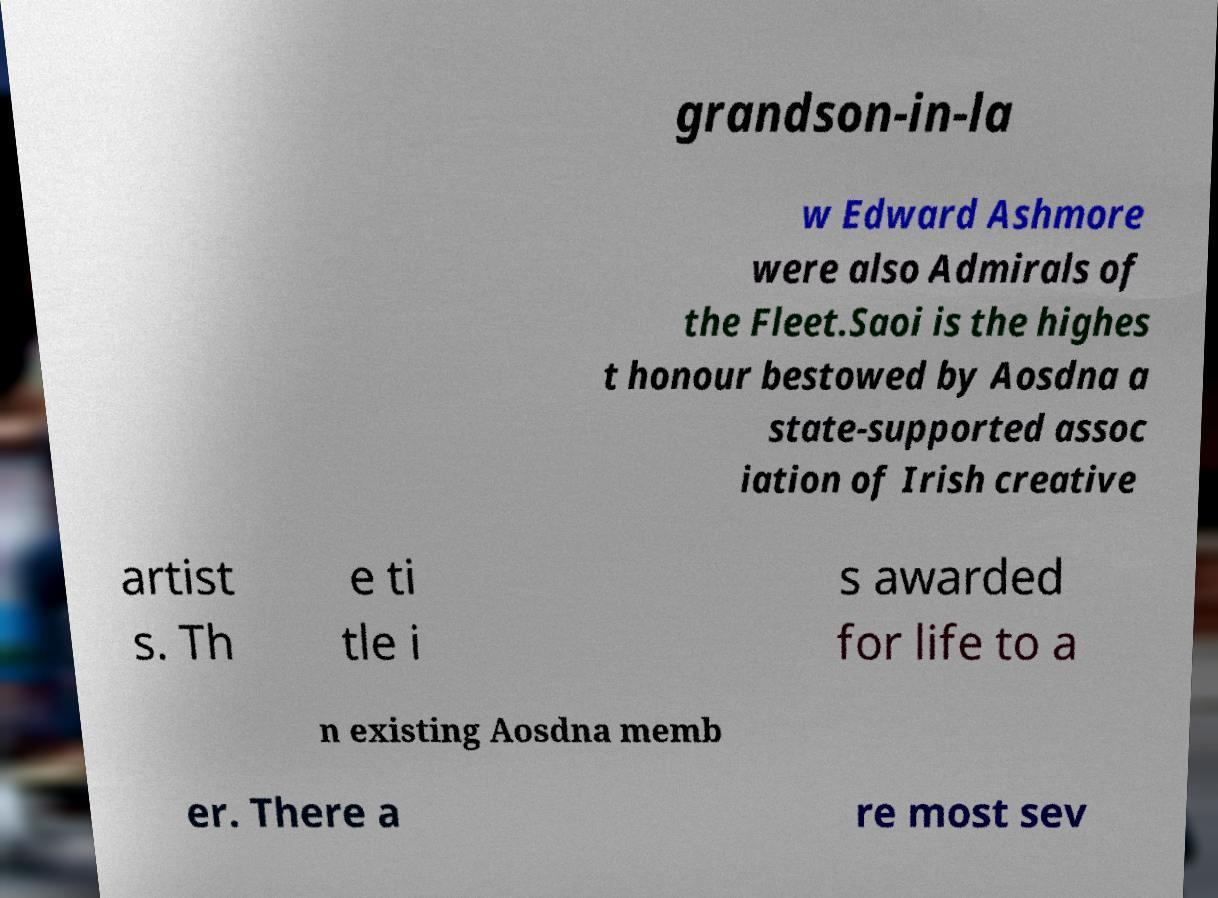I need the written content from this picture converted into text. Can you do that? grandson-in-la w Edward Ashmore were also Admirals of the Fleet.Saoi is the highes t honour bestowed by Aosdna a state-supported assoc iation of Irish creative artist s. Th e ti tle i s awarded for life to a n existing Aosdna memb er. There a re most sev 